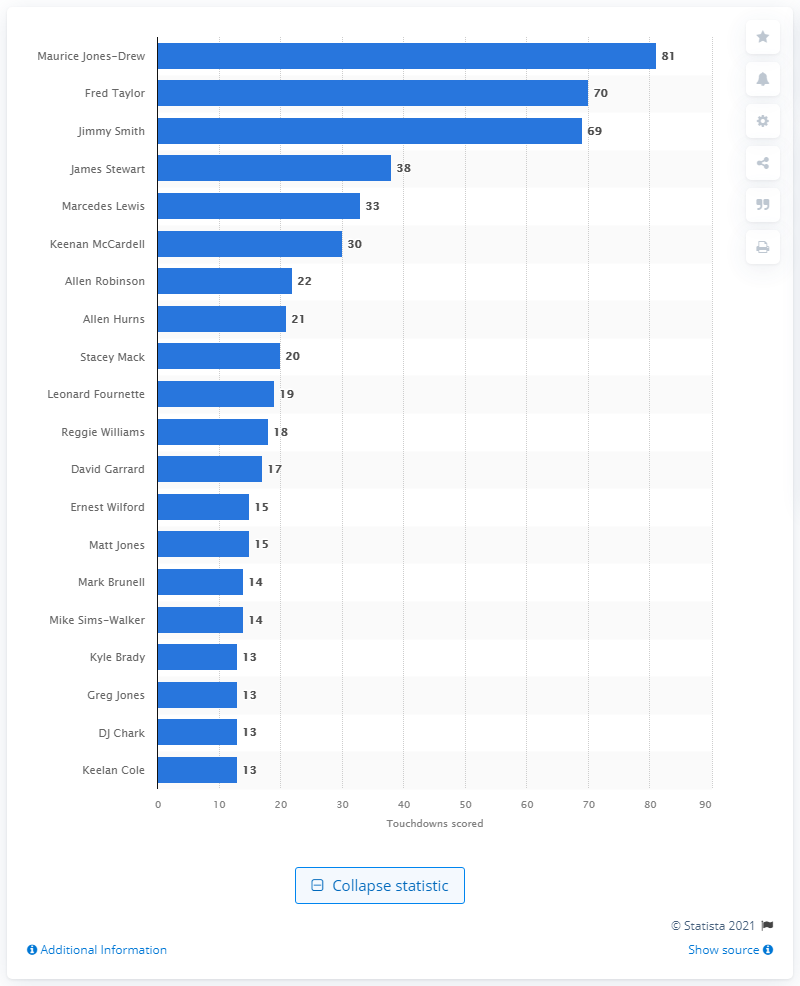Outline some significant characteristics in this image. Maurice Jones-Drew has scored 81 career touchdowns. Maurice Jones-Drew is the career touchdown leader of the Jacksonville Jaguars. 